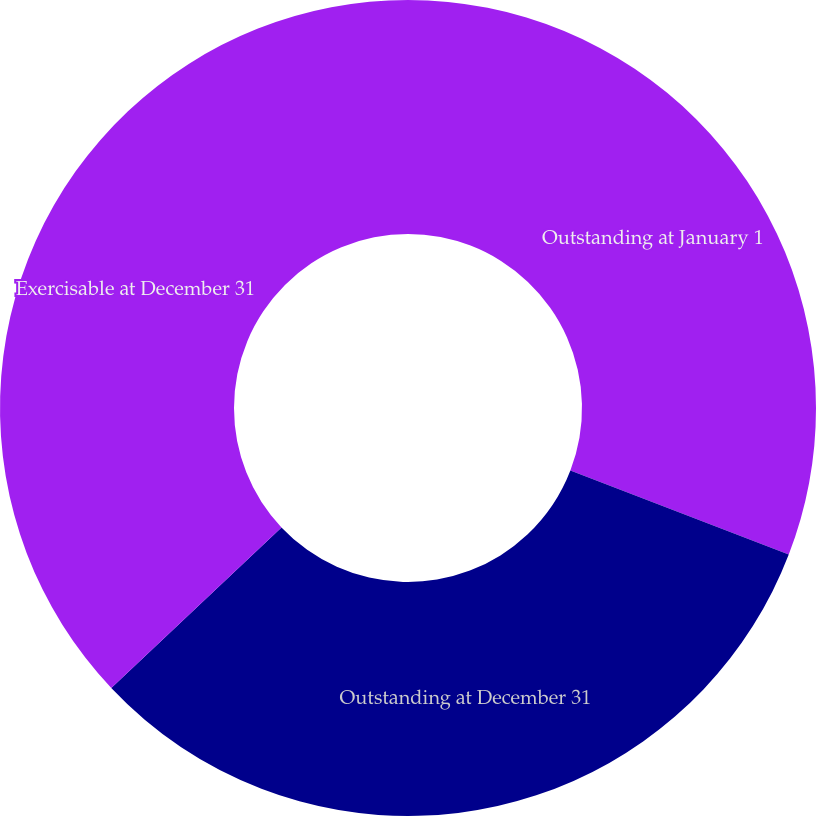Convert chart to OTSL. <chart><loc_0><loc_0><loc_500><loc_500><pie_chart><fcel>Outstanding at January 1<fcel>Outstanding at December 31<fcel>Exercisable at December 31<nl><fcel>30.85%<fcel>32.11%<fcel>37.04%<nl></chart> 